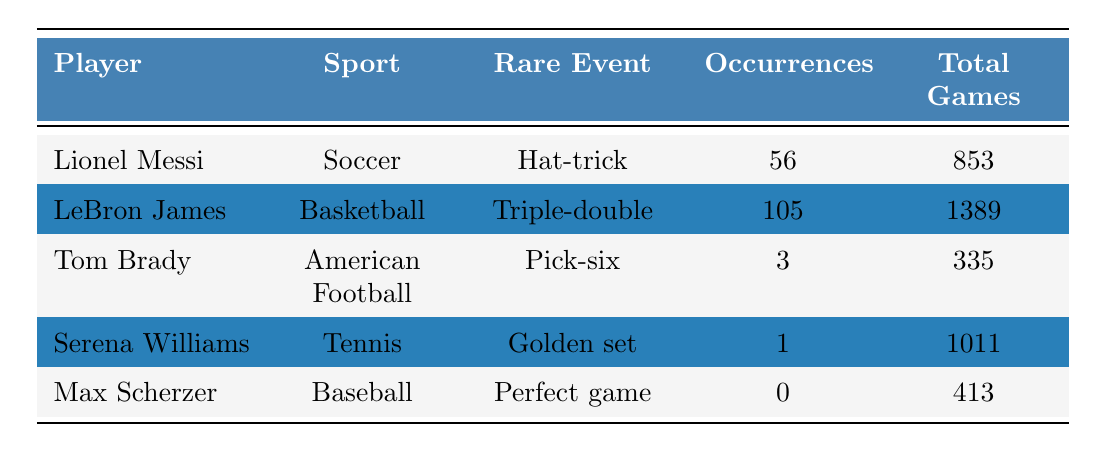What rare event did LeBron James achieve? According to the table, LeBron James achieved the rare event known as a Triple-double.
Answer: Triple-double How many occurrences of Hat-tricks does Lionel Messi have? The table states that Lionel Messi has 56 occurrences of Hat-tricks.
Answer: 56 Is the occurrence of Perfect games higher for Max Scherzer than that for Golden sets by Serena Williams? The table shows that Max Scherzer has 0 occurrences of Perfect games and Serena Williams has 1 occurrence of Golden sets, so the answer is no.
Answer: No What is the total number of games played by Tom Brady? The table indicates that Tom Brady has played a total of 335 games.
Answer: 335 Which player has the highest event occurrence rate among the listed events? To find the highest event occurrence rate, we calculate the occurrence rate for each player: Messi (56/853), LeBron (105/1389), Brady (3/335), Serena (1/1011), and Scherzer (0/413). Comparing these values, LeBron James has the highest occurrence rate at approximately 0.075.
Answer: LeBron James How many total games did the players have combined? To find the total games played, we add together all the total games for each player: 853 (Messi) + 1389 (LeBron) + 335 (Brady) + 1011 (Serena) + 413 (Scherzer) = 3991.
Answer: 3991 Does any player have more occurrences of their rare event than the total number of games in which Max Scherzer played? Max Scherzer played 413 games, and among the occurrences, Messi (56), LeBron (105), and Brady (3) all exceed 0 and are therefore greater than Scherzer's occurrence. The answer is yes.
Answer: Yes What was the rare event occurrence for Serena Williams and what sport does she play? The table states that Serena Williams achieved 1 Golden set and she plays Tennis.
Answer: 1 Golden set, Tennis Calculate the average occurrences of rare events across all players listed. The total occurrences are 56 (Messi) + 105 (LeBron) + 3 (Brady) + 1 (Serena) + 0 (Scherzer) = 165. There are 5 players, so the average is 165/5 = 33.
Answer: 33 Is there a correlation between the number of occurrences of rare events and the total games for players? A quick look indicates that while occurrences vary, there isn't enough evidence in the table to assert a clear correlation without further statistical analysis. Thus, the answer is no.
Answer: No 